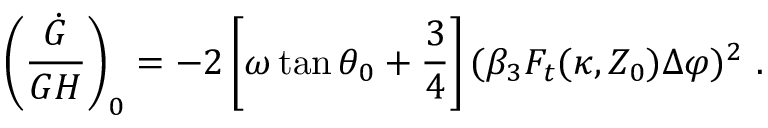Convert formula to latex. <formula><loc_0><loc_0><loc_500><loc_500>\left ( { \frac { \dot { G } } { G H } } \right ) _ { 0 } = - 2 \left [ \omega \tan \theta _ { 0 } + { \frac { 3 } { 4 } } \right ] ( \beta _ { 3 } F _ { t } ( \kappa , Z _ { 0 } ) \Delta \varphi ) ^ { 2 } \ .</formula> 